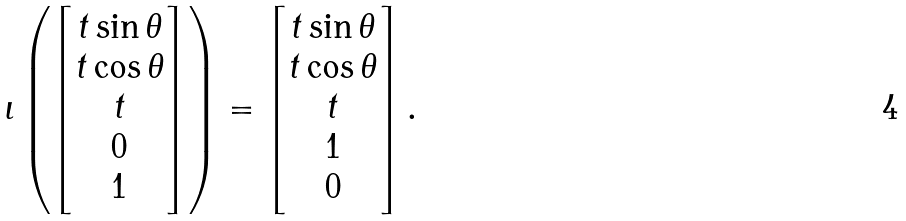Convert formula to latex. <formula><loc_0><loc_0><loc_500><loc_500>\iota \left ( \begin{bmatrix} t \sin \theta \\ t \cos \theta \\ t \\ 0 \\ 1 \end{bmatrix} \right ) = \begin{bmatrix} t \sin \theta \\ t \cos \theta \\ t \\ 1 \\ 0 \end{bmatrix} .</formula> 